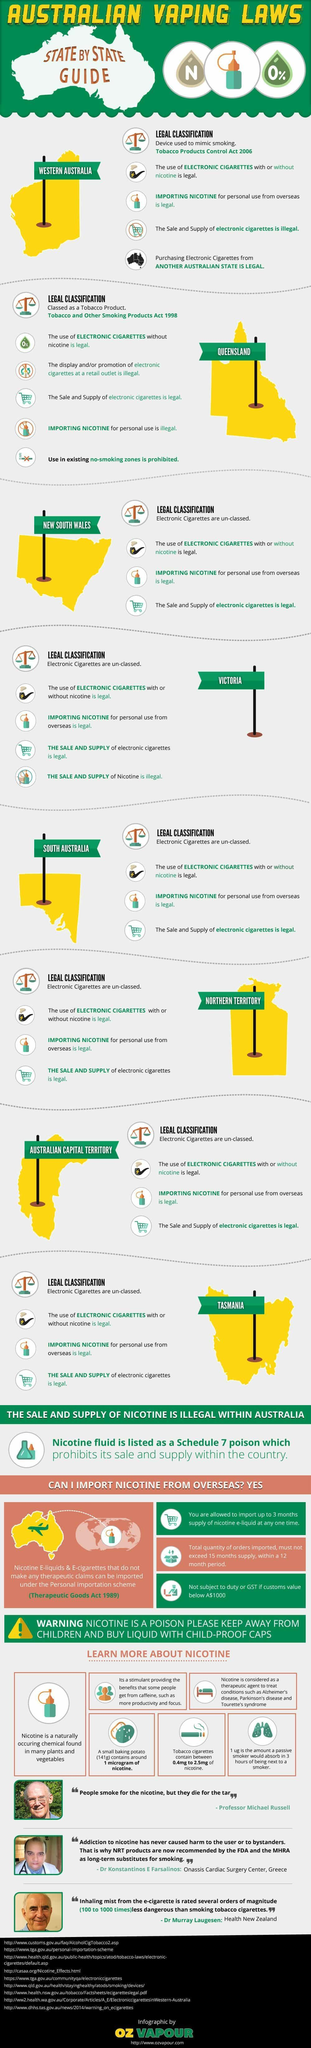In which state is importing nicotine for personal use illegal?
Answer the question with a short phrase. Queensland What is considered as therapeutic agent in treating conditions like Parkinson's disease? nicotine In which state is e-cigarette with nicotine illegal? Queensland In which state is sale and supply of electronic cigarettes illegal? Western Australia In which state is e-cigarette classified as a device used to mimic smoking? Western Australia In which state is e-cigarette classed as a tobacco product? Queensland Which chemical mentioned here is a stimulant similar to caffeine? nicotine How is an e-cigarette classed in Western Australia? Device used to mimic smoking As per which Act can nicotine e-liquids be imported? Therapeutic Goods Act 1989 